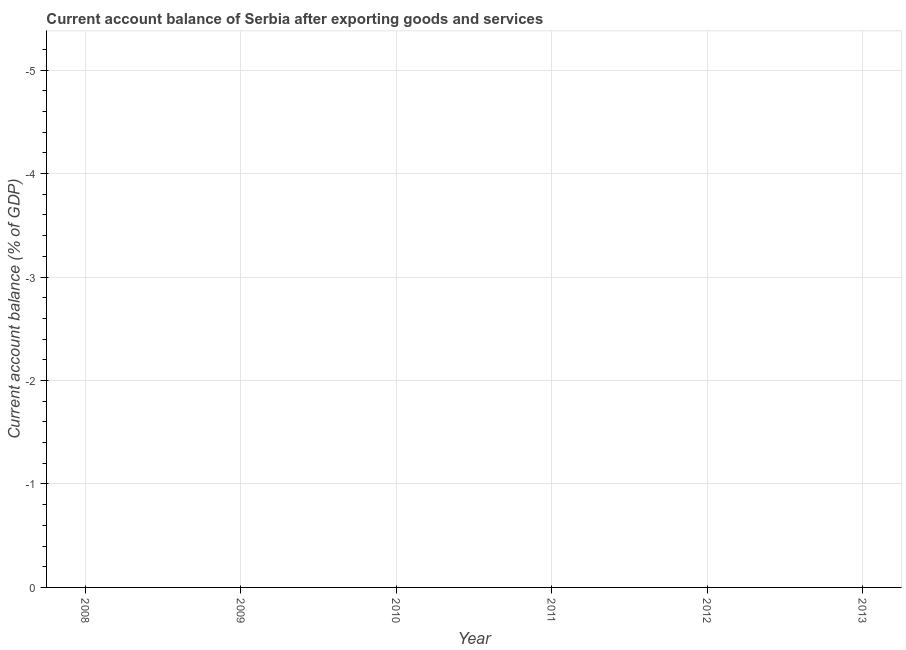What is the current account balance in 2012?
Give a very brief answer. 0. Across all years, what is the minimum current account balance?
Your answer should be compact. 0. What is the median current account balance?
Your answer should be compact. 0. In how many years, is the current account balance greater than -3.4 %?
Offer a very short reply. 0. How many dotlines are there?
Make the answer very short. 0. Does the graph contain any zero values?
Your answer should be very brief. Yes. What is the title of the graph?
Your answer should be compact. Current account balance of Serbia after exporting goods and services. What is the label or title of the X-axis?
Your answer should be very brief. Year. What is the label or title of the Y-axis?
Give a very brief answer. Current account balance (% of GDP). What is the Current account balance (% of GDP) in 2008?
Make the answer very short. 0. What is the Current account balance (% of GDP) in 2010?
Give a very brief answer. 0. What is the Current account balance (% of GDP) in 2011?
Make the answer very short. 0. What is the Current account balance (% of GDP) in 2012?
Ensure brevity in your answer.  0. 